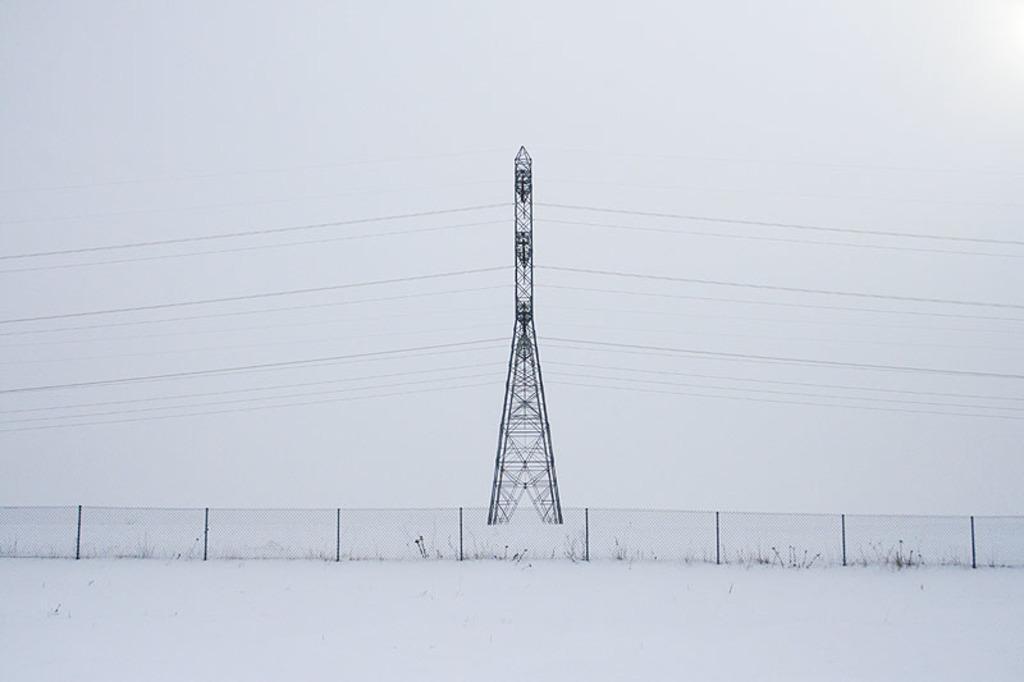In one or two sentences, can you explain what this image depicts? This picture is clicked outside the city. In the foreground we can see there is a lot of snow. In the center we can see the metal rods and a mesh and there is pole and cables. In the background there is a sky. 